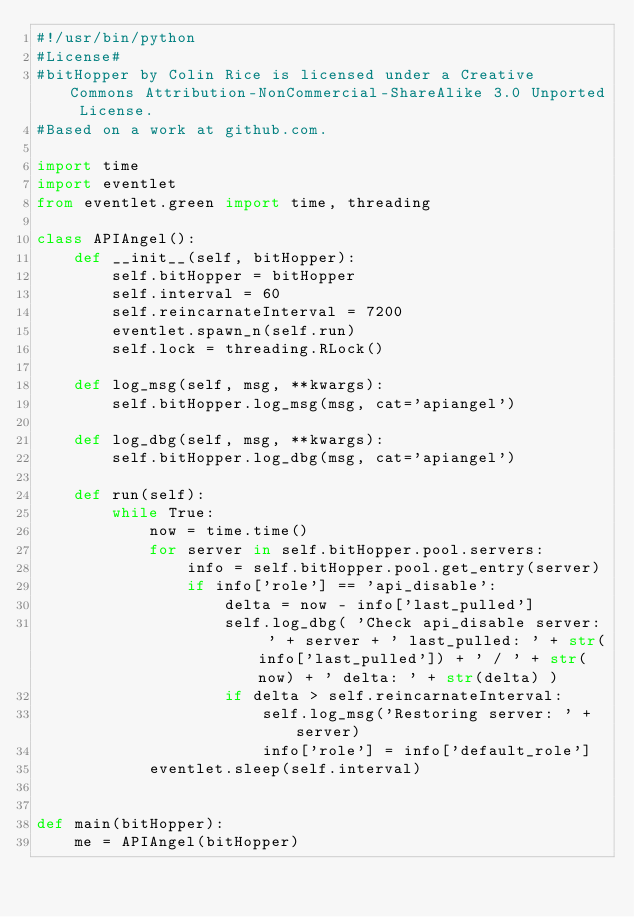<code> <loc_0><loc_0><loc_500><loc_500><_Python_>#!/usr/bin/python
#License#
#bitHopper by Colin Rice is licensed under a Creative Commons Attribution-NonCommercial-ShareAlike 3.0 Unported License.
#Based on a work at github.com.

import time
import eventlet
from eventlet.green import time, threading

class APIAngel():
    def __init__(self, bitHopper):
        self.bitHopper = bitHopper
        self.interval = 60
        self.reincarnateInterval = 7200
        eventlet.spawn_n(self.run)
        self.lock = threading.RLock()
            
    def log_msg(self, msg, **kwargs):
        self.bitHopper.log_msg(msg, cat='apiangel')
        
    def log_dbg(self, msg, **kwargs):
        self.bitHopper.log_dbg(msg, cat='apiangel')
        
    def run(self):
        while True:
            now = time.time()
            for server in self.bitHopper.pool.servers:
                info = self.bitHopper.pool.get_entry(server)
                if info['role'] == 'api_disable':
                    delta = now - info['last_pulled']
                    self.log_dbg( 'Check api_disable server: ' + server + ' last_pulled: ' + str(info['last_pulled']) + ' / ' + str(now) + ' delta: ' + str(delta) )                    
                    if delta > self.reincarnateInterval:
                        self.log_msg('Restoring server: ' + server)
                        info['role'] = info['default_role']
            eventlet.sleep(self.interval)


def main(bitHopper):
    me = APIAngel(bitHopper)

    
</code> 